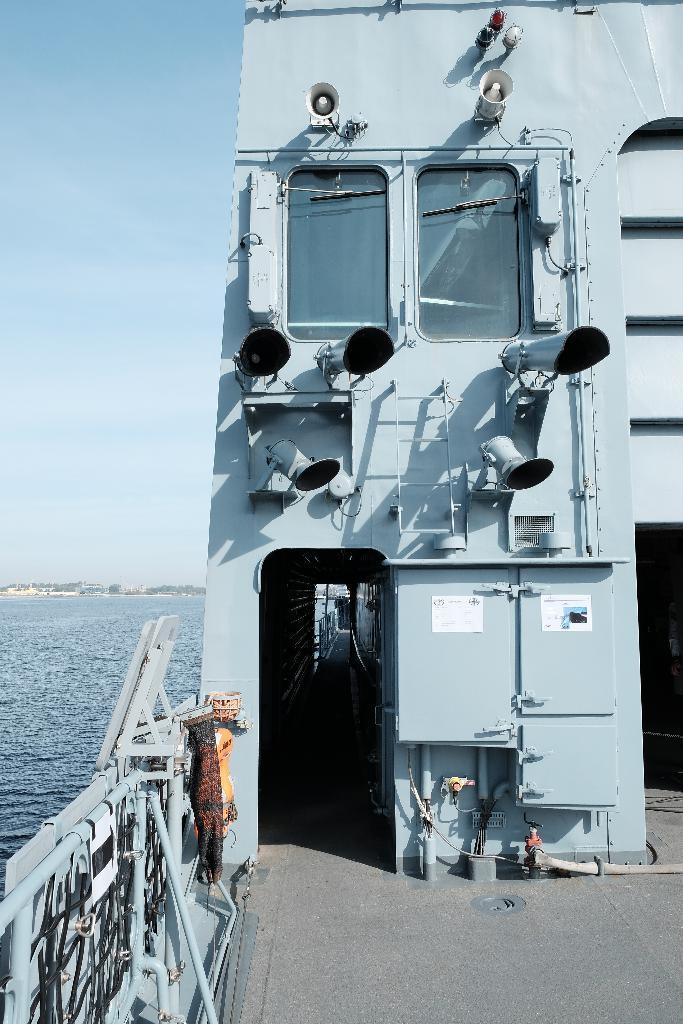Could you give a brief overview of what you see in this image? In this image in the foreground there is one ship, and there are some pipes rods and some objects. At the top there are two speakers and in the background there is a beach, and at the top of the image there is sky. 